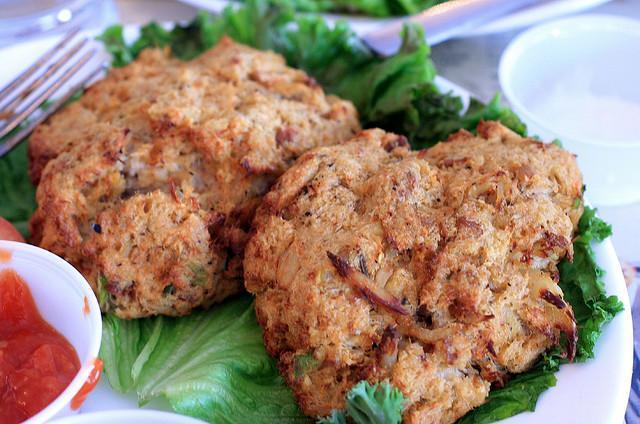How many bowls are there?
Give a very brief answer. 2. How many sandwiches can you see?
Give a very brief answer. 2. 